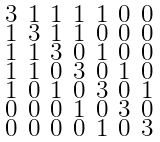<formula> <loc_0><loc_0><loc_500><loc_500>\begin{smallmatrix} 3 & 1 & 1 & 1 & 1 & 0 & 0 \\ 1 & 3 & 1 & 1 & 0 & 0 & 0 \\ 1 & 1 & 3 & 0 & 1 & 0 & 0 \\ 1 & 1 & 0 & 3 & 0 & 1 & 0 \\ 1 & 0 & 1 & 0 & 3 & 0 & 1 \\ 0 & 0 & 0 & 1 & 0 & 3 & 0 \\ 0 & 0 & 0 & 0 & 1 & 0 & 3 \end{smallmatrix}</formula> 